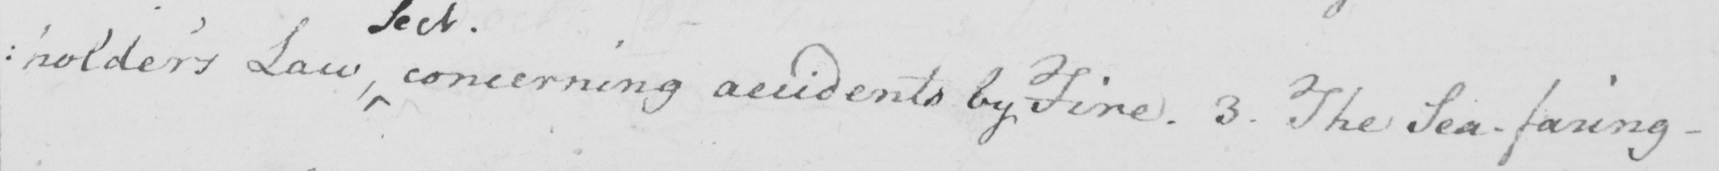Please provide the text content of this handwritten line. : holder ' s Law , concerning accidents by Fire . 3 . The Sea-faring- 